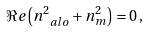<formula> <loc_0><loc_0><loc_500><loc_500>\Re e \left ( n _ { \ a l o } ^ { 2 } + n _ { m } ^ { 2 } \right ) = 0 \, ,</formula> 